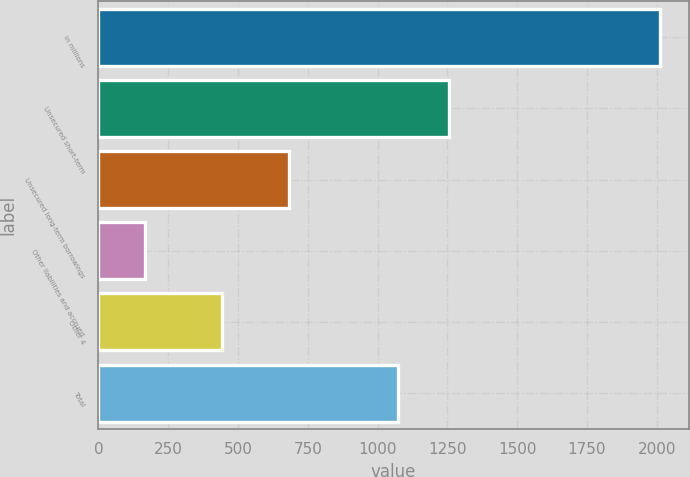Convert chart to OTSL. <chart><loc_0><loc_0><loc_500><loc_500><bar_chart><fcel>in millions<fcel>Unsecured short-term<fcel>Unsecured long-term borrowings<fcel>Other liabilities and accrued<fcel>Other 4<fcel>Total<nl><fcel>2013<fcel>1256.6<fcel>683<fcel>167<fcel>443<fcel>1072<nl></chart> 